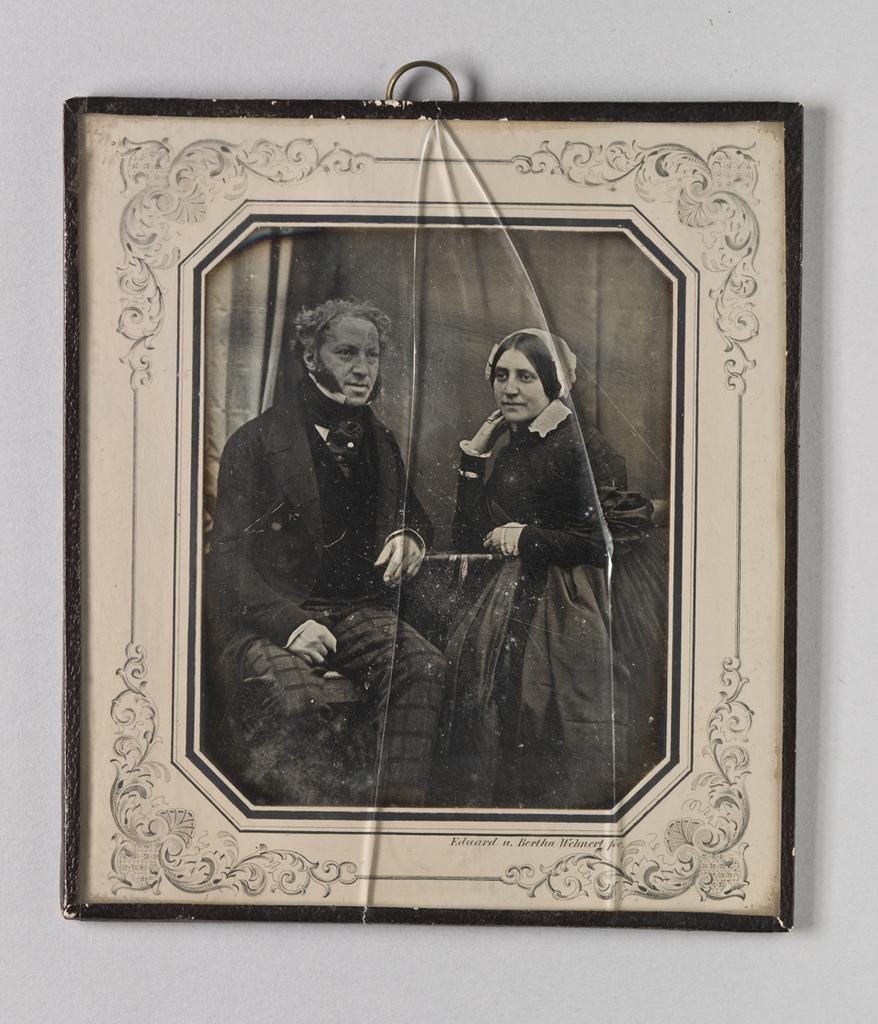What is hanging on the wall in the center of the picture? There is a frame hung on the wall in the center of the picture. What is inside the frame? The frame contains a black and white photograph. What is depicted in the photograph? The photograph depicts a couple. How many mittens can be seen in the photograph? There are no mittens present in the photograph; it depicts a couple. What is the degree of the angle at which the couple is standing in the photograph? The facts provided do not give information about the angle at which the couple is standing, nor is there any mention of angles or degrees in the image. 